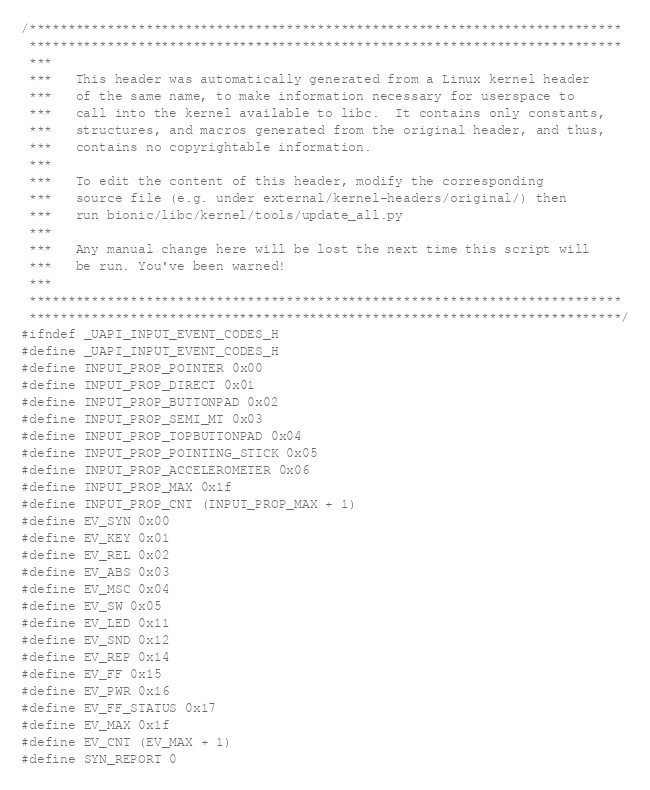Convert code to text. <code><loc_0><loc_0><loc_500><loc_500><_C_>/****************************************************************************
 ****************************************************************************
 ***
 ***   This header was automatically generated from a Linux kernel header
 ***   of the same name, to make information necessary for userspace to
 ***   call into the kernel available to libc.  It contains only constants,
 ***   structures, and macros generated from the original header, and thus,
 ***   contains no copyrightable information.
 ***
 ***   To edit the content of this header, modify the corresponding
 ***   source file (e.g. under external/kernel-headers/original/) then
 ***   run bionic/libc/kernel/tools/update_all.py
 ***
 ***   Any manual change here will be lost the next time this script will
 ***   be run. You've been warned!
 ***
 ****************************************************************************
 ****************************************************************************/
#ifndef _UAPI_INPUT_EVENT_CODES_H
#define _UAPI_INPUT_EVENT_CODES_H
#define INPUT_PROP_POINTER 0x00
#define INPUT_PROP_DIRECT 0x01
#define INPUT_PROP_BUTTONPAD 0x02
#define INPUT_PROP_SEMI_MT 0x03
#define INPUT_PROP_TOPBUTTONPAD 0x04
#define INPUT_PROP_POINTING_STICK 0x05
#define INPUT_PROP_ACCELEROMETER 0x06
#define INPUT_PROP_MAX 0x1f
#define INPUT_PROP_CNT (INPUT_PROP_MAX + 1)
#define EV_SYN 0x00
#define EV_KEY 0x01
#define EV_REL 0x02
#define EV_ABS 0x03
#define EV_MSC 0x04
#define EV_SW 0x05
#define EV_LED 0x11
#define EV_SND 0x12
#define EV_REP 0x14
#define EV_FF 0x15
#define EV_PWR 0x16
#define EV_FF_STATUS 0x17
#define EV_MAX 0x1f
#define EV_CNT (EV_MAX + 1)
#define SYN_REPORT 0</code> 